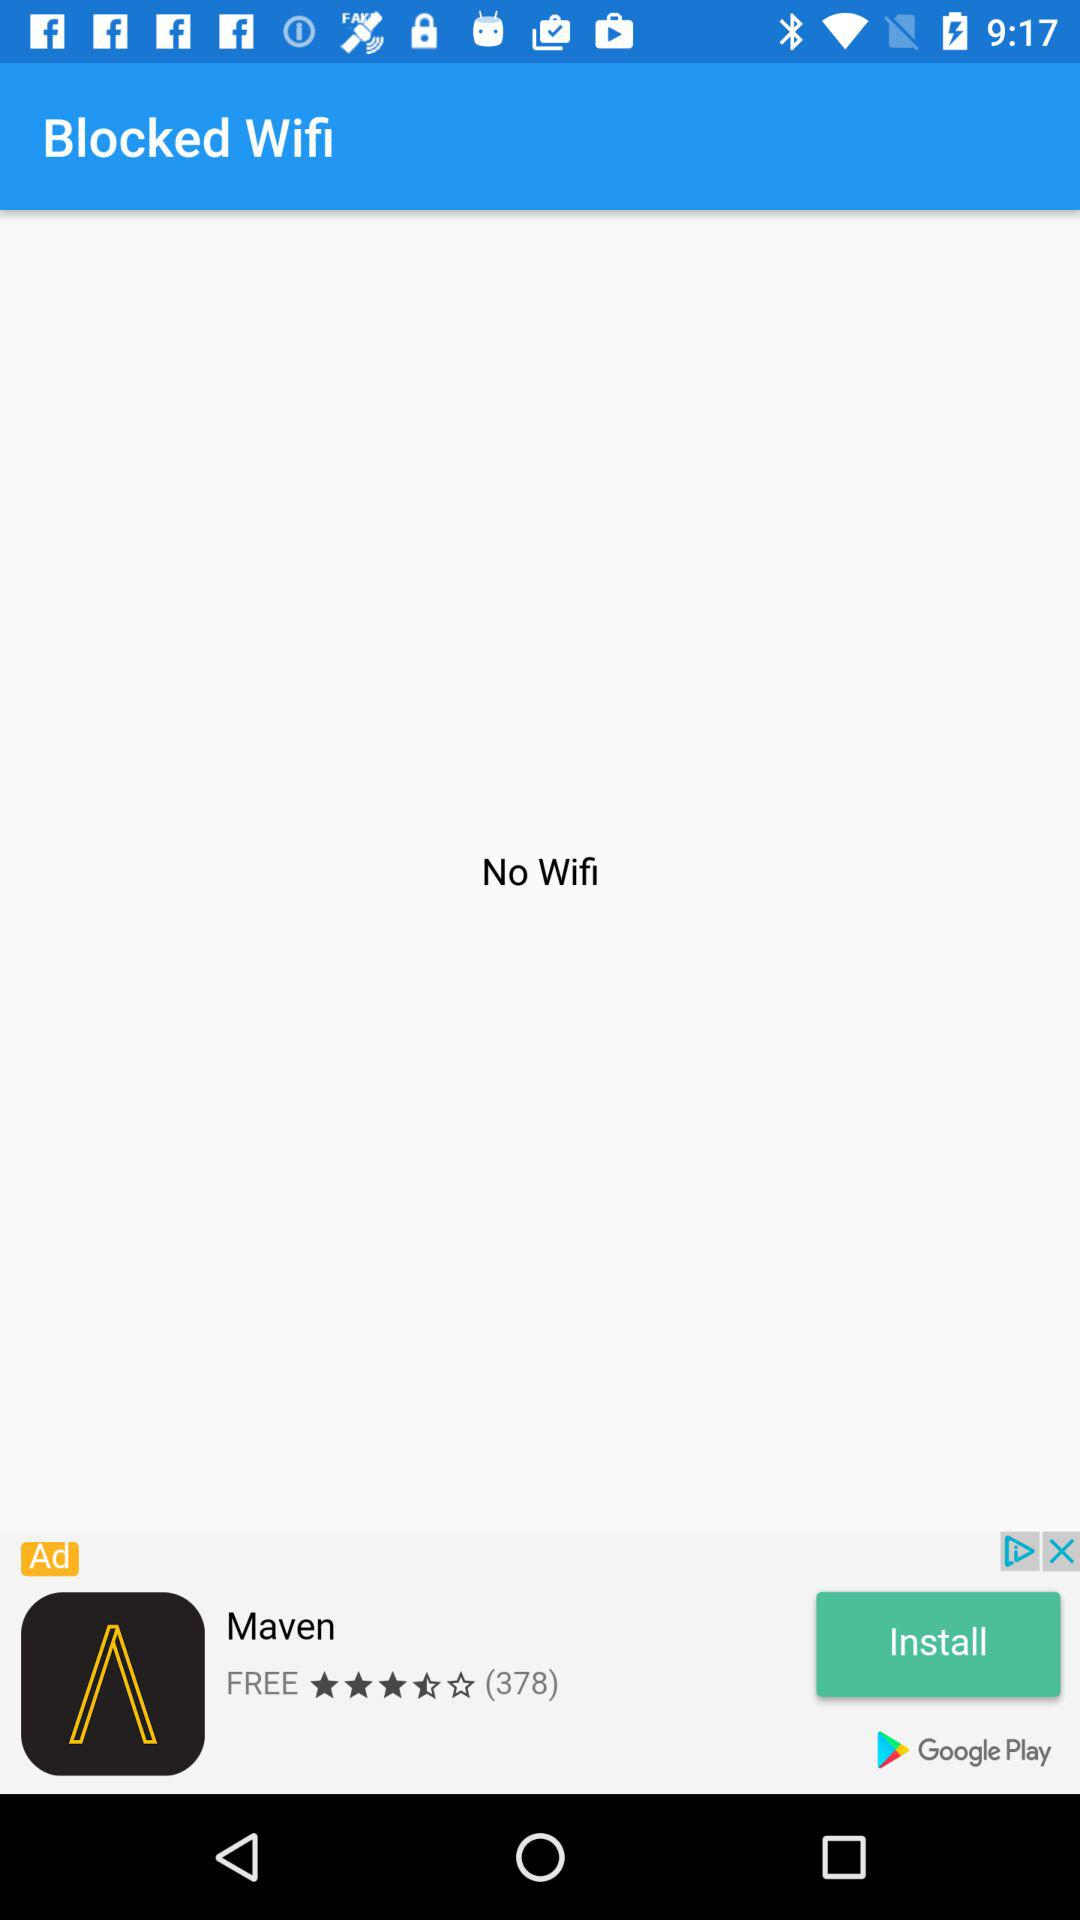Is there any blocked wifi? There is no blocked wifi. 